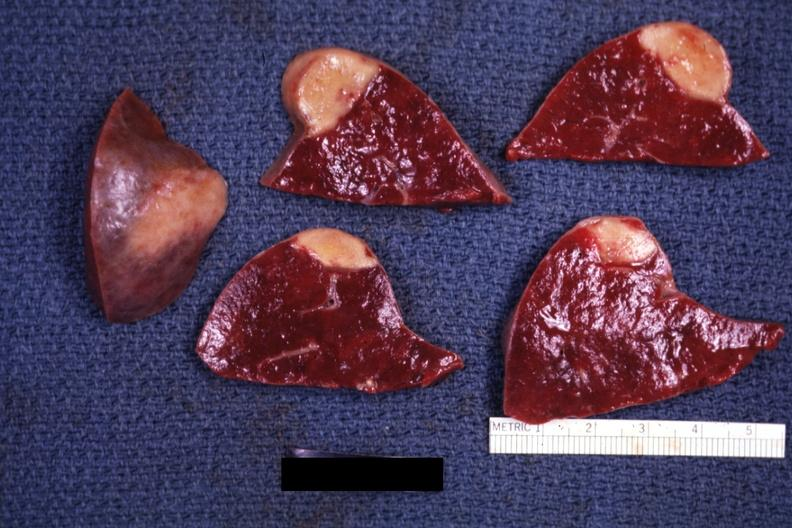where is this part in?
Answer the question using a single word or phrase. Spleen 